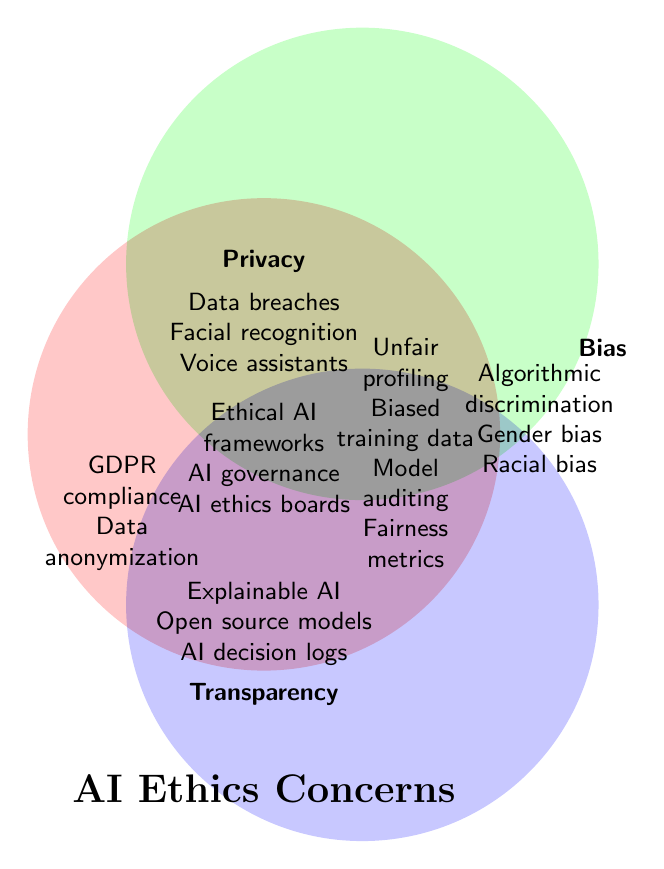What are the three AI ethics concerns described in the figure? The figure labels three main concerns: Privacy, Bias, and Transparency. This can be seen from the larger circular areas in the Venn diagram.
Answer: Privacy, Bias, Transparency Which category includes 'Facial recognition'? Locate 'Facial recognition' within one of the circles. It is found in the Privacy section.
Answer: Privacy Which categories overlap for 'Unfair profiling' and 'Biased training data'? 'Unfair profiling' and 'Biased training data' are located in the overlapping area between the Privacy and Bias circles.
Answer: Privacy & Bias What concerns are shared by all three categories? The center area where all three circles overlapped includes 'Ethical AI frameworks', 'AI governance', and 'AI ethics boards'.
Answer: Ethical AI frameworks, AI governance, AI ethics boards Which concern is mentioned in the overlap of Bias and Transparency but not in Privacy? 'Model auditing' and 'Fairness metrics' appear in the overlapping section between Bias and Transparency, but they are not part of Privacy.
Answer: Model auditing, Fairness metrics Which concepts are exclusive to Bias? Check within the Bias circle but outside the overlapping areas. The concepts exclusive to Bias are 'Algorithmic discrimination', 'Gender bias', and 'Racial bias'.
Answer: Algorithmic discrimination, Gender bias, Racial bias How many concepts are listed under Transparency? Count all unique items within and overlapping the Transparency circle. They are 'Explainable AI', 'Open source models', 'AI decision logs', 'Model auditing', 'Fairness metrics', and 'Ethical AI frameworks'.
Answer: 6 Which intersection category includes 'Data anonymization'? 'Data anonymization' is seen in the overlapping area of Privacy and Transparency.
Answer: Privacy & Transparency Which section includes 'GDPR compliance'? 'GDPR compliance' is found in the overlap of Privacy and Transparency.
Answer: Privacy & Transparency What are the overlaps specific to Privacy and Transparency, but not including Bias? 'Data anonymization' and 'GDPR compliance' are listed in the Privacy and Transparency overlap area, excluding Bias.
Answer: Data anonymization, GDPR compliance 